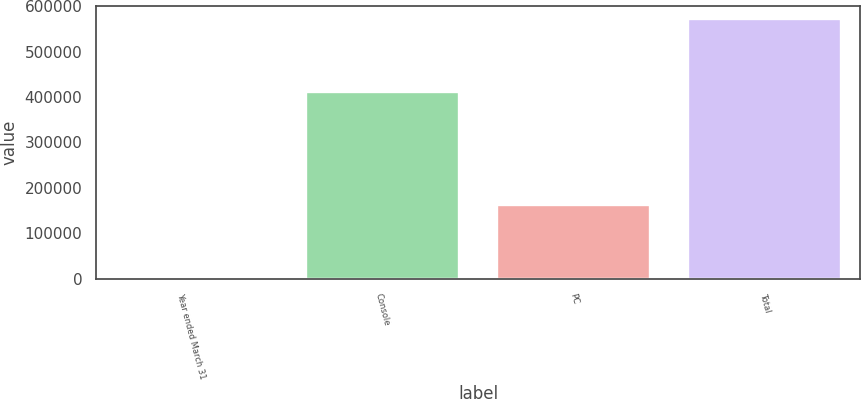Convert chart to OTSL. <chart><loc_0><loc_0><loc_500><loc_500><bar_chart><fcel>Year ended March 31<fcel>Console<fcel>PC<fcel>Total<nl><fcel>2000<fcel>410277<fcel>161928<fcel>572205<nl></chart> 